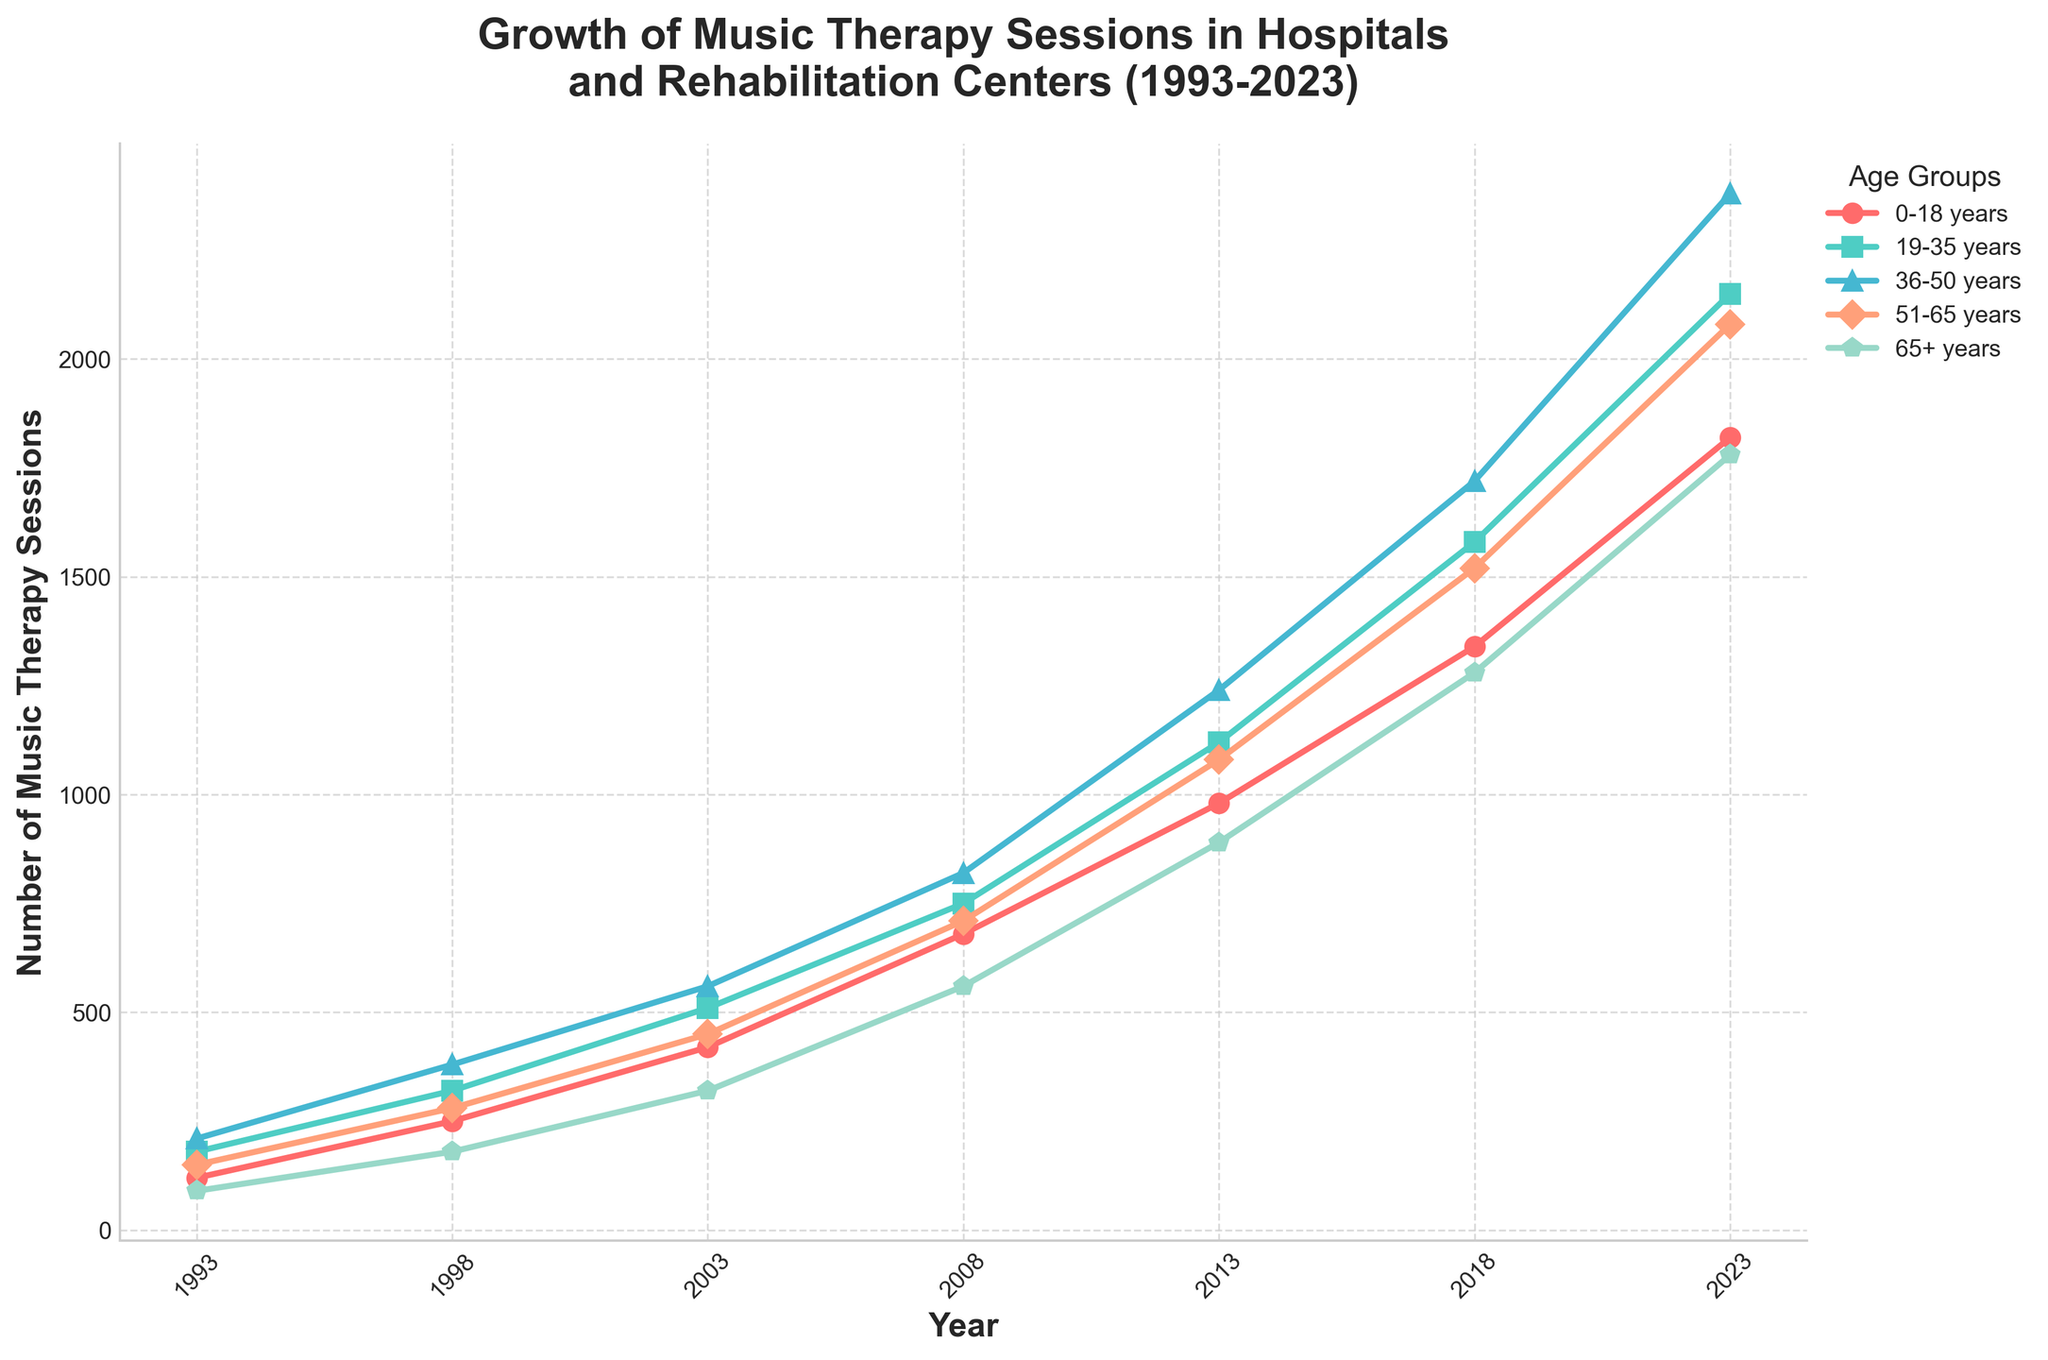Which age group experienced the most significant growth in music therapy sessions from 1993 to 2023? The growth is determined by the difference between the number of sessions in 2023 and 1993 for each age group. For 0-18 years: 1820 - 120 = 1700, for 19-35 years: 2150 - 180 = 1970, for 36-50 years: 2380 - 210 = 2170, for 51-65 years: 2080 - 150 = 1930, for 65+ years: 1780 - 90 = 1690. The 36-50 years group experienced the most significant growth.
Answer: 36-50 years Which age group had the highest number of music therapy sessions in 2023? By observing the heights of the lines representing each age group at the year 2023, the 36-50 years age group has the highest value.
Answer: 36-50 years Between which consecutive years was the highest increase in sessions observed for the 51-65 years age group? Looking at the 51-65 years age group values: 150 (1993), 280 (1998), 450 (2003), 710 (2008), 1080 (2013), 1520 (2018), 2080 (2023). The differences are: 180, 170, 260, 370, 440, 560. The highest increase occurred between 2018 and 2023.
Answer: 2018-2023 What is the total number of music therapy sessions for the 19-35 years age group over all the years provided? Summing up the sessions: 180 + 320 + 510 + 750 + 1120 + 1580 + 2150 = 6610
Answer: 6610 Which age group has the smallest percentage growth in music therapy sessions from 1993 to 2023? Calculating the percentage growth for each age group: (1820 - 120) / 120 * 100 ≈ 1417%, (2150 - 180) / 180 * 100 ≈ 1094%, (2380 - 210) / 210 * 100 ≈ 1033%, (2080 - 150) / 150 * 100 ≈ 1287%, (1780 - 90) / 90 * 100 ≈ 1878%. The 36-50 years group has the smallest percentage growth.
Answer: 36-50 years How did the number of music therapy sessions for the 0-18 years age group change from 2003 to 2023? The number of sessions in 2003 for the 0-18 years group is 420, and in 2023 it is 1820. The change is 1820 - 420 = 1400.
Answer: Increased by 1400 Which age group had the lowest number of music therapy sessions in 1993 and how many sessions were there? Observing the values for 1993, the 65+ years age group had the lowest number with 90 sessions.
Answer: 65+ years, 90 What is the average number of music therapy sessions in 2013 across all age groups? Summing the sessions for 2013: 980 + 1120 + 1240 + 1080 + 890 = 5310, then dividing by the number of age groups, 5310 / 5 = 1062
Answer: 1062 Compare the total number of sessions between the 19-35 years and 36-50 years age groups over the 30 years. Which group has more sessions and by what amount? Summing the sessions for 19-35 years: 180 + 320 + 510 + 750 + 1120 + 1580 + 2150 = 6610, for 36-50 years: 210 + 380 + 560 + 820 + 1240 + 1720 + 2380 = 7310. The 36-50 years group has more sessions by 7310 - 6610 = 700.
Answer: 36-50 years, 700 